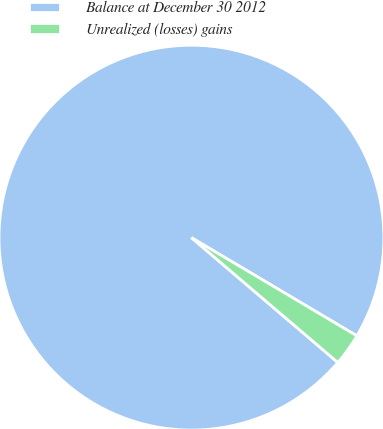Convert chart. <chart><loc_0><loc_0><loc_500><loc_500><pie_chart><fcel>Balance at December 30 2012<fcel>Unrealized (losses) gains<nl><fcel>97.29%<fcel>2.71%<nl></chart> 